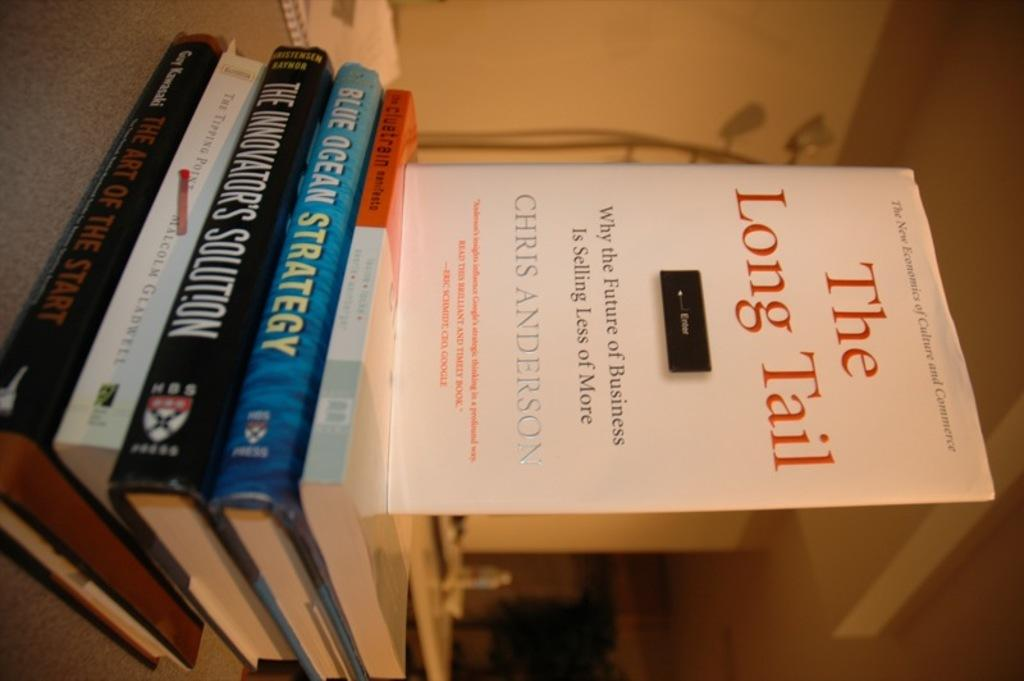<image>
Give a short and clear explanation of the subsequent image. A few books with dust jackets and a book about why selling less is more is the future of business. 